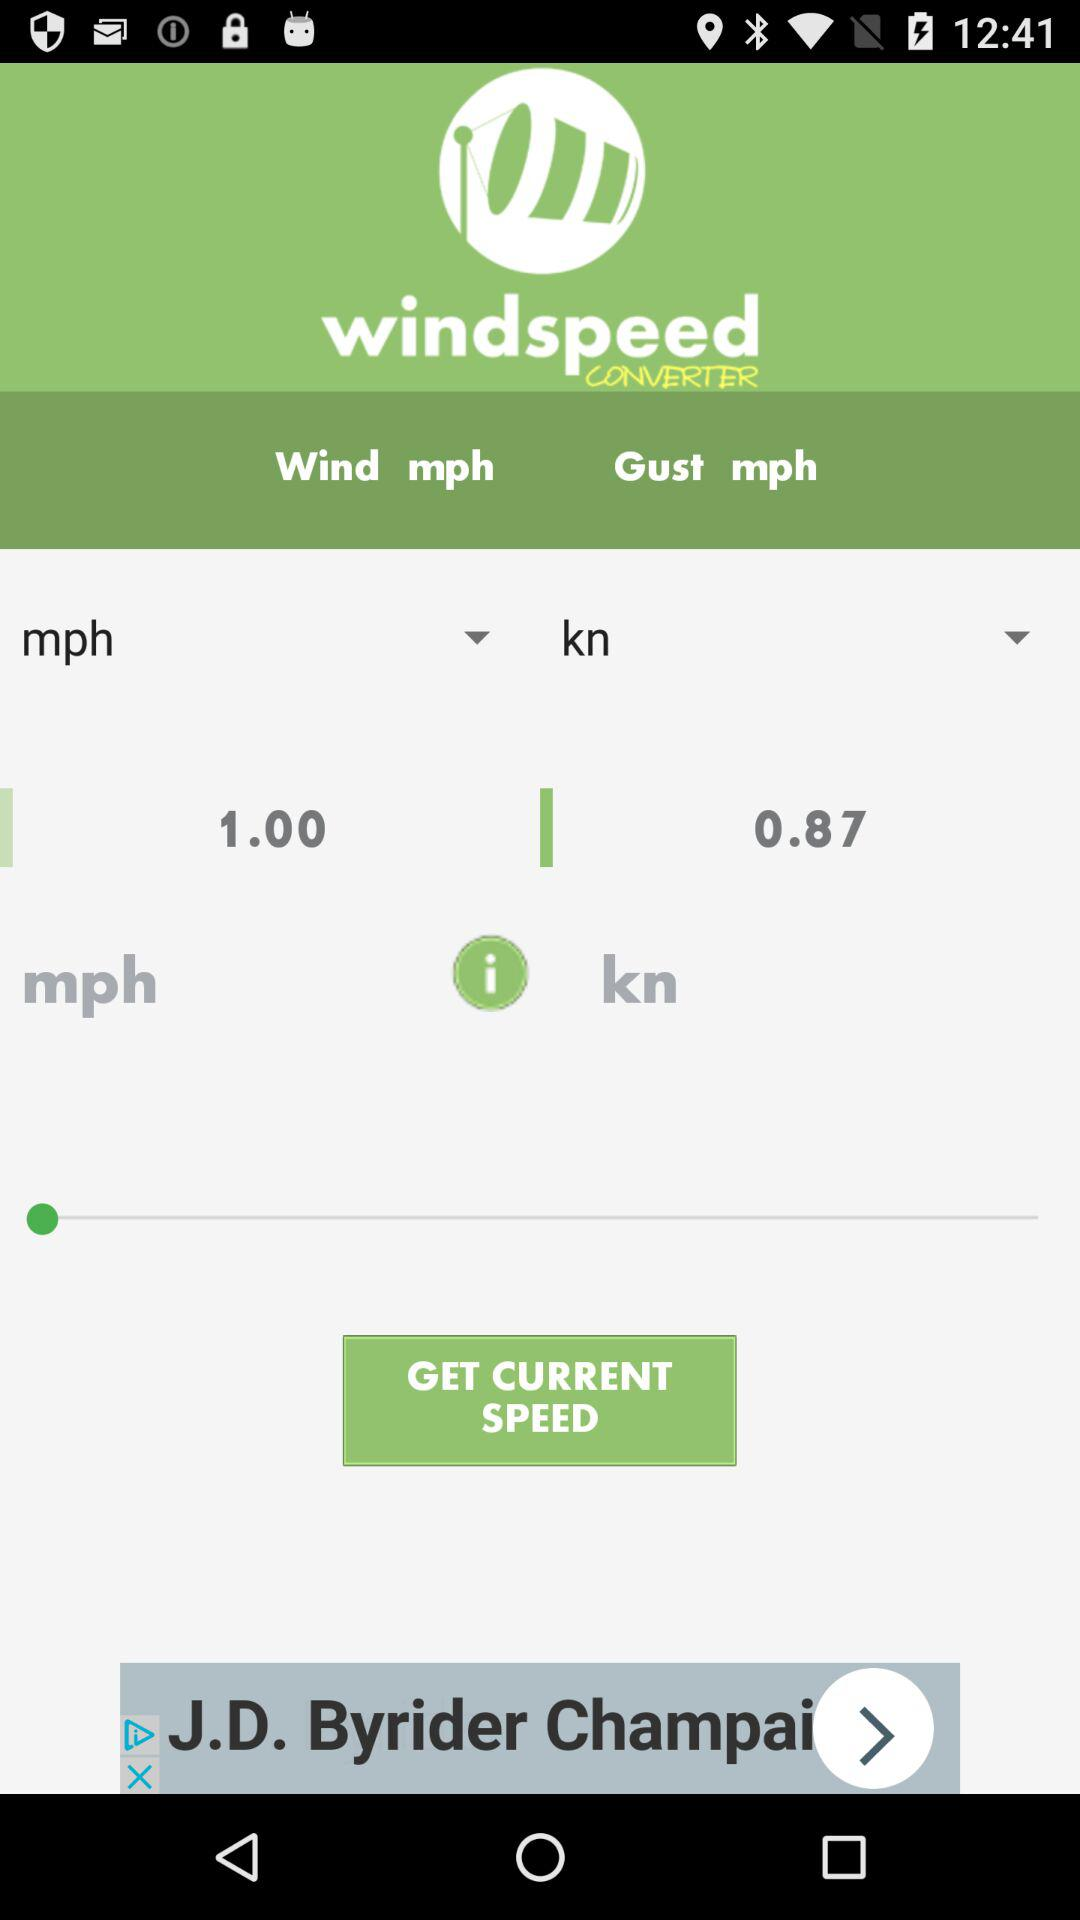What is the application name? The application name is "windspeed CONVERTER". 